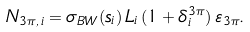Convert formula to latex. <formula><loc_0><loc_0><loc_500><loc_500>N _ { 3 \pi , \, i } = \sigma _ { B W } ( s _ { i } ) \, L _ { i } \, ( 1 + \delta ^ { 3 \pi } _ { i } ) \, \varepsilon _ { 3 \pi } .</formula> 